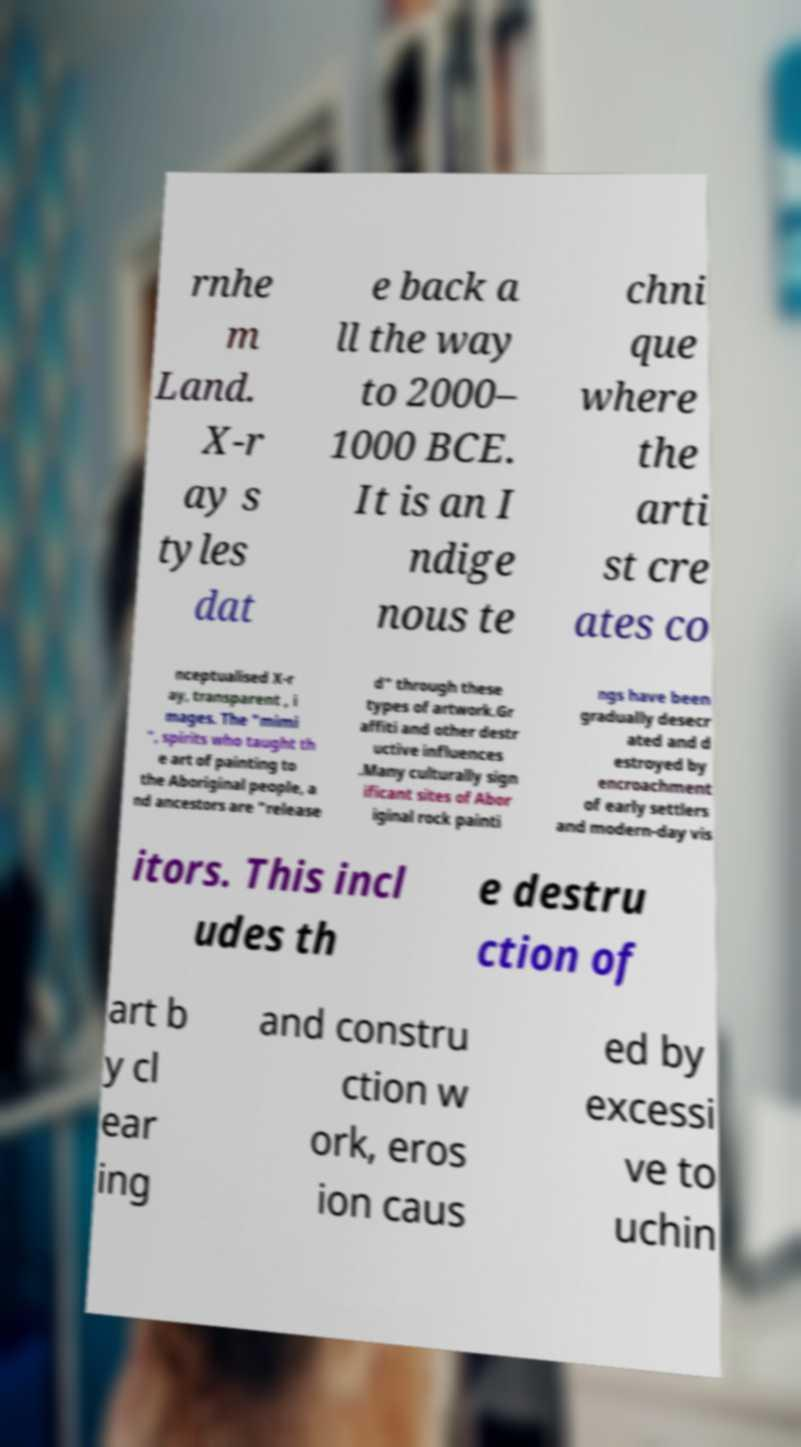Please read and relay the text visible in this image. What does it say? rnhe m Land. X-r ay s tyles dat e back a ll the way to 2000– 1000 BCE. It is an I ndige nous te chni que where the arti st cre ates co nceptualised X-r ay, transparent , i mages. The "mimi ", spirits who taught th e art of painting to the Aboriginal people, a nd ancestors are "release d" through these types of artwork.Gr affiti and other destr uctive influences .Many culturally sign ificant sites of Abor iginal rock painti ngs have been gradually desecr ated and d estroyed by encroachment of early settlers and modern-day vis itors. This incl udes th e destru ction of art b y cl ear ing and constru ction w ork, eros ion caus ed by excessi ve to uchin 